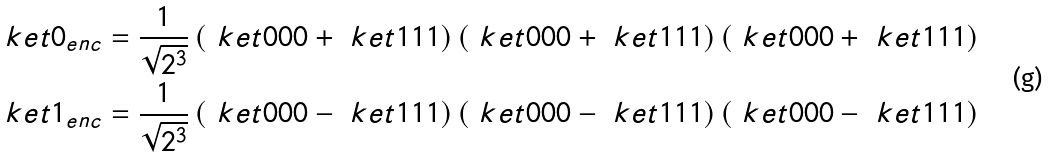Convert formula to latex. <formula><loc_0><loc_0><loc_500><loc_500>& \ k e t { 0 } _ { e n c } = \frac { 1 } { \sqrt { 2 ^ { 3 } } } \left ( \ k e t { 0 0 0 } + \ k e t { 1 1 1 } \right ) \left ( \ k e t { 0 0 0 } + \ k e t { 1 1 1 } \right ) \left ( \ k e t { 0 0 0 } + \ k e t { 1 1 1 } \right ) \\ & \ k e t { 1 } _ { e n c } = \frac { 1 } { \sqrt { 2 ^ { 3 } } } \left ( \ k e t { 0 0 0 } - \ k e t { 1 1 1 } \right ) \left ( \ k e t { 0 0 0 } - \ k e t { 1 1 1 } \right ) \left ( \ k e t { 0 0 0 } - \ k e t { 1 1 1 } \right )</formula> 